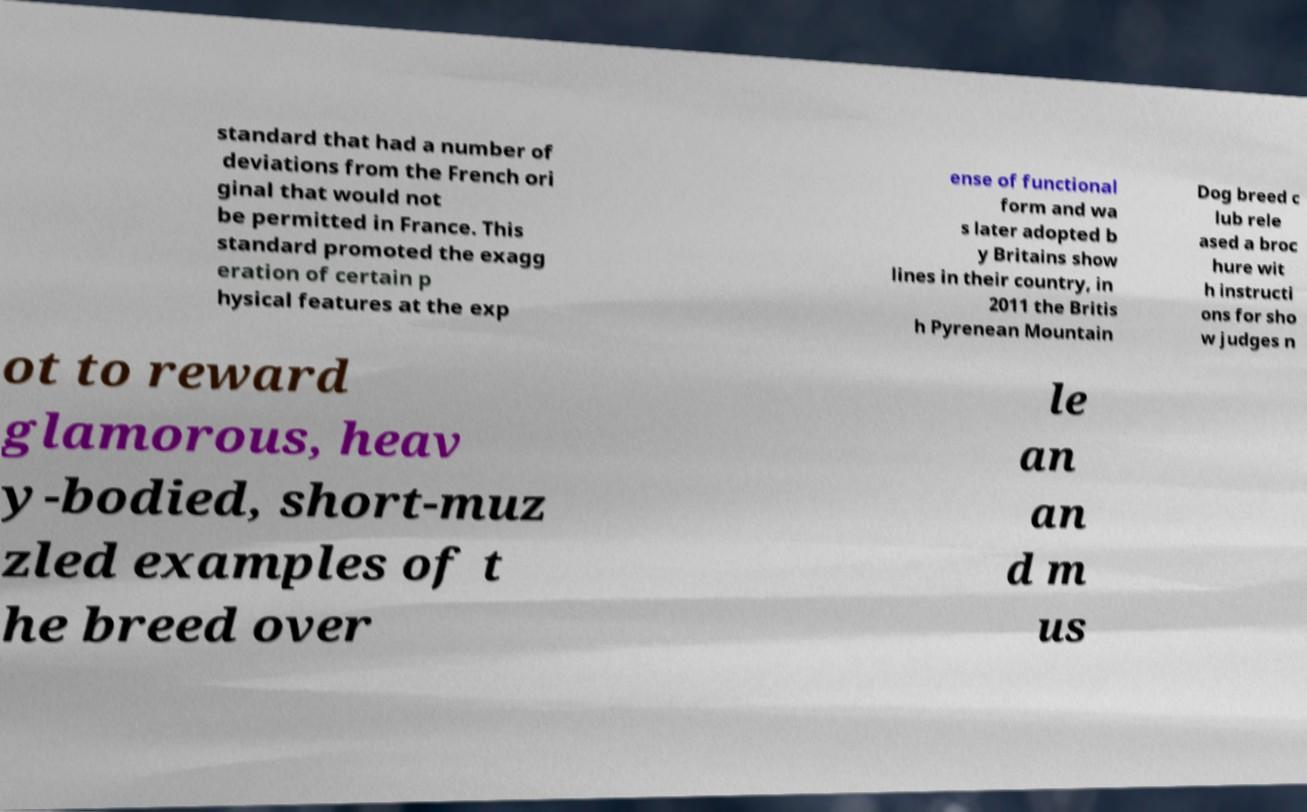For documentation purposes, I need the text within this image transcribed. Could you provide that? standard that had a number of deviations from the French ori ginal that would not be permitted in France. This standard promoted the exagg eration of certain p hysical features at the exp ense of functional form and wa s later adopted b y Britains show lines in their country, in 2011 the Britis h Pyrenean Mountain Dog breed c lub rele ased a broc hure wit h instructi ons for sho w judges n ot to reward glamorous, heav y-bodied, short-muz zled examples of t he breed over le an an d m us 